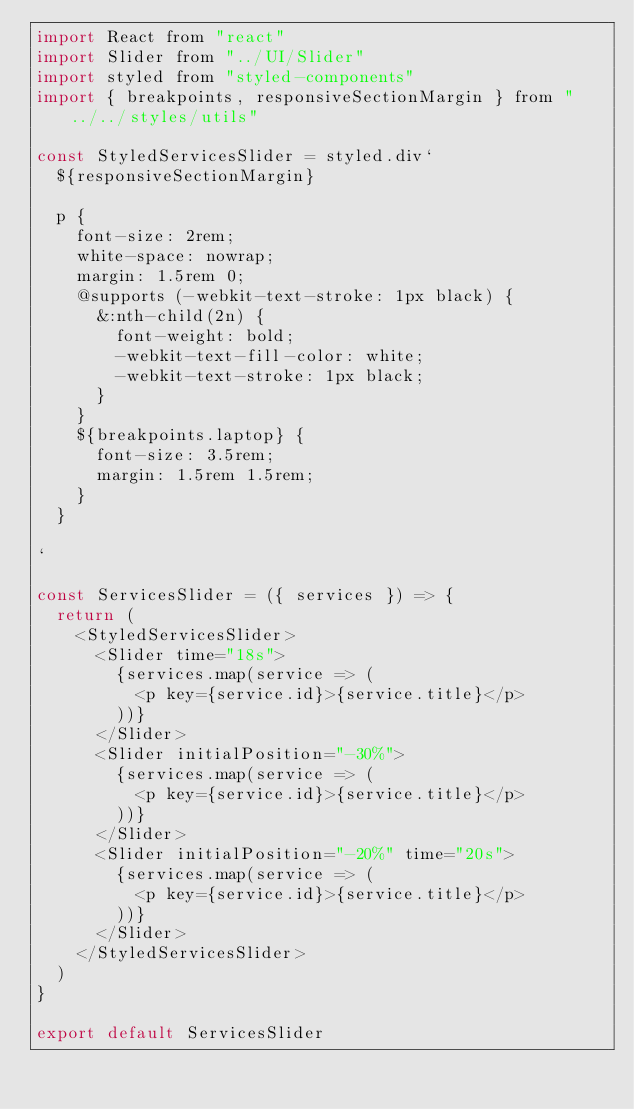Convert code to text. <code><loc_0><loc_0><loc_500><loc_500><_JavaScript_>import React from "react"
import Slider from "../UI/Slider"
import styled from "styled-components"
import { breakpoints, responsiveSectionMargin } from "../../styles/utils"

const StyledServicesSlider = styled.div`
  ${responsiveSectionMargin}

  p {
    font-size: 2rem;
    white-space: nowrap;
    margin: 1.5rem 0;
    @supports (-webkit-text-stroke: 1px black) {
      &:nth-child(2n) {
        font-weight: bold;
        -webkit-text-fill-color: white;
        -webkit-text-stroke: 1px black;
      }
    }
    ${breakpoints.laptop} {
      font-size: 3.5rem;
      margin: 1.5rem 1.5rem;
    }
  }

`

const ServicesSlider = ({ services }) => {
  return (
    <StyledServicesSlider>
      <Slider time="18s">
        {services.map(service => (
          <p key={service.id}>{service.title}</p>
        ))}
      </Slider>
      <Slider initialPosition="-30%">
        {services.map(service => (
          <p key={service.id}>{service.title}</p>
        ))}
      </Slider>
      <Slider initialPosition="-20%" time="20s">
        {services.map(service => (
          <p key={service.id}>{service.title}</p>
        ))}
      </Slider>
    </StyledServicesSlider>
  )
}

export default ServicesSlider
</code> 